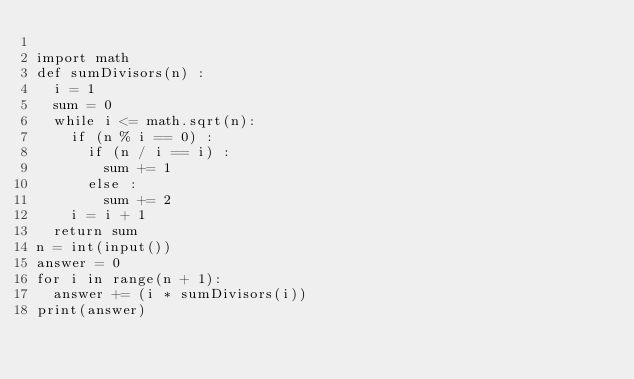<code> <loc_0><loc_0><loc_500><loc_500><_Python_>
import math 
def sumDivisors(n) :
  i = 1
  sum = 0
  while i <= math.sqrt(n):
    if (n % i == 0) :
      if (n / i == i) :
        sum += 1
      else :
        sum += 2
    i = i + 1
  return sum
n = int(input())
answer = 0
for i in range(n + 1):
  answer += (i * sumDivisors(i))
print(answer)
</code> 